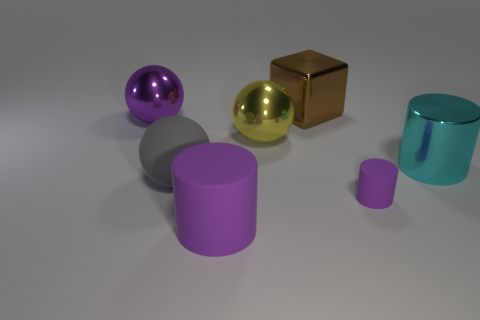Subtract all purple cylinders. How many were subtracted if there are1purple cylinders left? 1 Add 1 objects. How many objects exist? 8 Subtract all balls. How many objects are left? 4 Add 5 big gray cylinders. How many big gray cylinders exist? 5 Subtract 0 yellow cylinders. How many objects are left? 7 Subtract all cyan metallic objects. Subtract all large cyan cylinders. How many objects are left? 5 Add 3 large purple cylinders. How many large purple cylinders are left? 4 